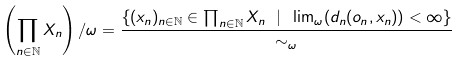<formula> <loc_0><loc_0><loc_500><loc_500>\left ( \prod _ { n \in \mathbb { N } } X _ { n } \right ) / \omega = \frac { \{ ( x _ { n } ) _ { n \in \mathbb { N } } \in \prod _ { n \in \mathbb { N } } X _ { n } \ | \ \lim _ { \omega } ( d _ { n } ( o _ { n } , x _ { n } ) ) < \infty \} } { \sim _ { \omega } }</formula> 